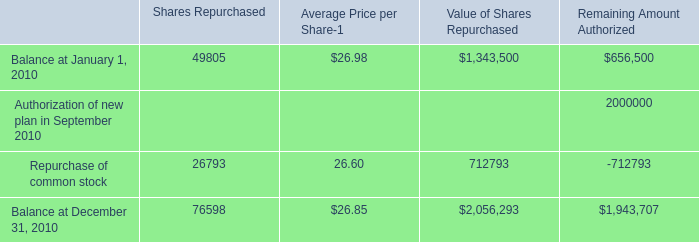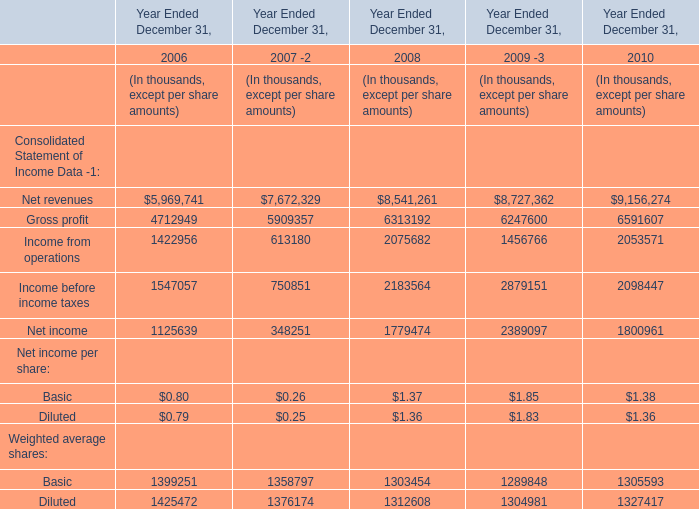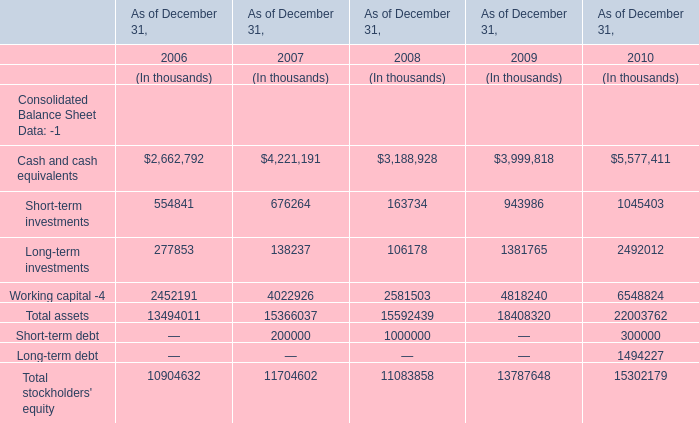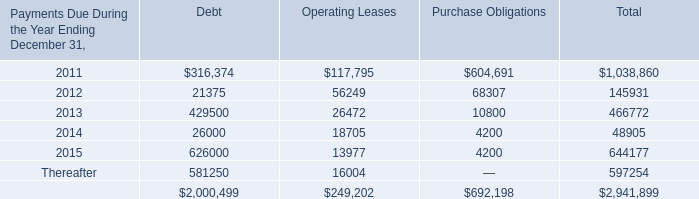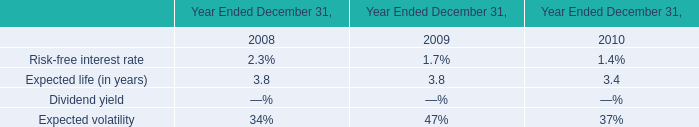If gross profit develops with the same growth rate in 2010, what will it reach in 2011? (in thousand) 
Computations: ((((6591607 - 6247600) / 6247600) + 1) * 6591607)
Answer: 6954555.80422. 